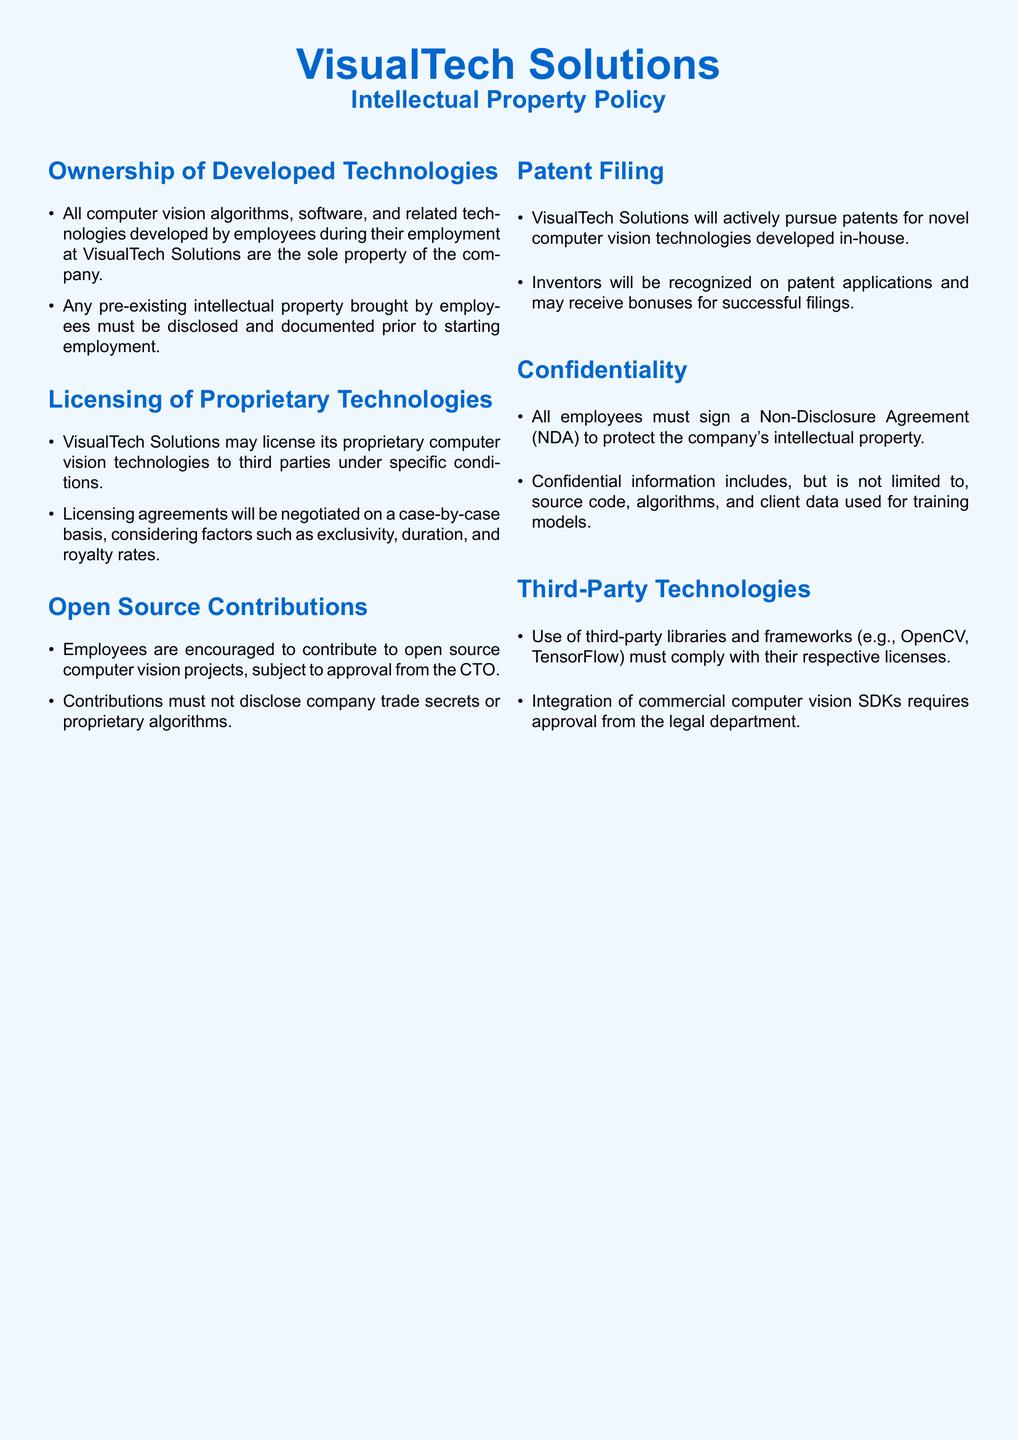What is the title of the document? The title of the document is prominently displayed at the top, which identifies it as a policy document.
Answer: Intellectual Property Policy Who owns the computer vision technologies developed by employees? The ownership clause specifies that the company possesses all technologies developed by employees during employment.
Answer: The company What must employees disclose before starting employment? The document states that any pre-existing intellectual property must be disclosed and documented.
Answer: Pre-existing intellectual property What is required for licensing proprietary technologies to third parties? The document mentions that licensing agreements will be negotiated on a case-by-case basis under specific conditions.
Answer: Negotiation Who must approve open source contributions? The policy indicates that contributions to open source projects need approval from a designated officer.
Answer: CTO What will VisualTech Solutions pursue for novel technologies? The document states the company will actively pursue legal protection for new technologies.
Answer: Patents What must employees sign to protect the company's intellectual property? The confidentiality section outlines the need for employees to sign a specific type of legal agreement.
Answer: Non-Disclosure Agreement (NDA) What must be complied with when using third-party libraries? The document stipulates that usage of external libraries must follow the legal requirements set by the vendors.
Answer: Their respective licenses Who will be recognized on patent applications? The patent filing section specifies that the inventors of the technologies will receive acknowledgment for their contributions.
Answer: Inventors 